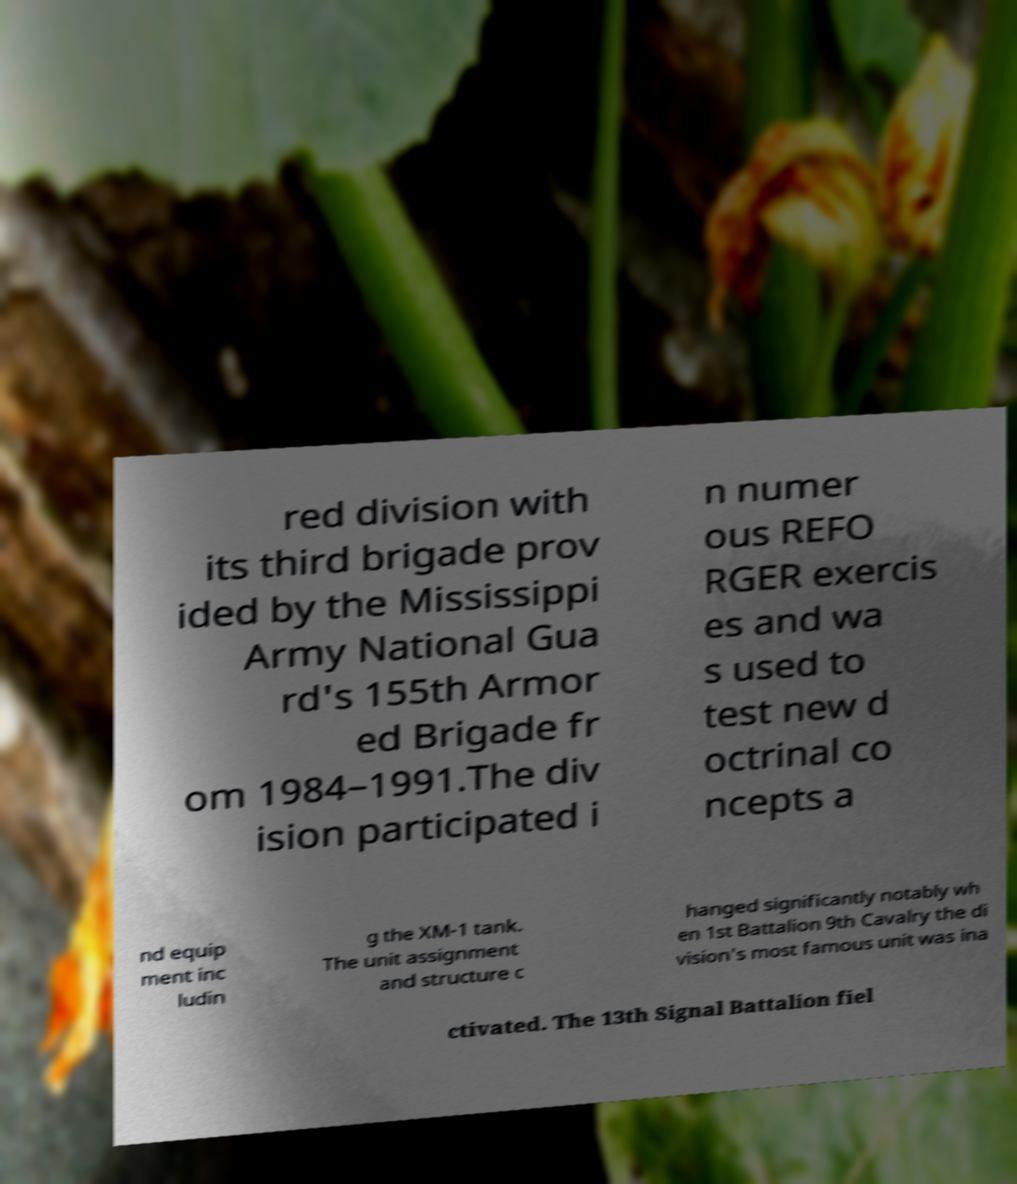Please read and relay the text visible in this image. What does it say? red division with its third brigade prov ided by the Mississippi Army National Gua rd's 155th Armor ed Brigade fr om 1984–1991.The div ision participated i n numer ous REFO RGER exercis es and wa s used to test new d octrinal co ncepts a nd equip ment inc ludin g the XM-1 tank. The unit assignment and structure c hanged significantly notably wh en 1st Battalion 9th Cavalry the di vision's most famous unit was ina ctivated. The 13th Signal Battalion fiel 